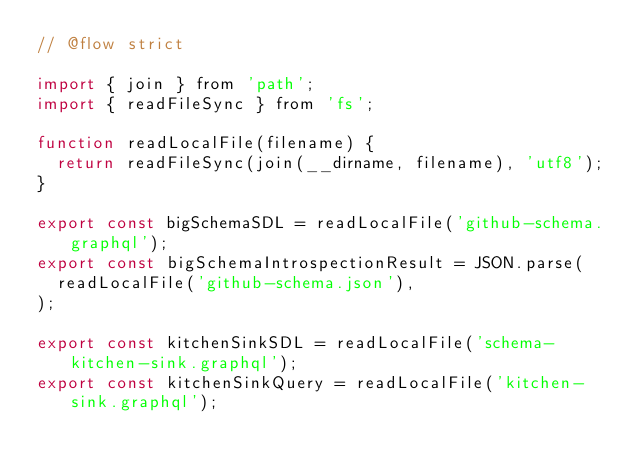Convert code to text. <code><loc_0><loc_0><loc_500><loc_500><_JavaScript_>// @flow strict

import { join } from 'path';
import { readFileSync } from 'fs';

function readLocalFile(filename) {
  return readFileSync(join(__dirname, filename), 'utf8');
}

export const bigSchemaSDL = readLocalFile('github-schema.graphql');
export const bigSchemaIntrospectionResult = JSON.parse(
  readLocalFile('github-schema.json'),
);

export const kitchenSinkSDL = readLocalFile('schema-kitchen-sink.graphql');
export const kitchenSinkQuery = readLocalFile('kitchen-sink.graphql');
</code> 